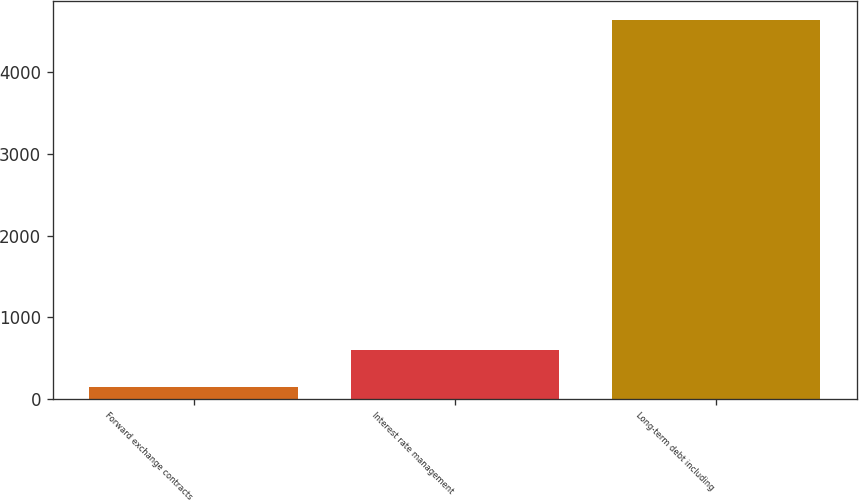<chart> <loc_0><loc_0><loc_500><loc_500><bar_chart><fcel>Forward exchange contracts<fcel>Interest rate management<fcel>Long-term debt including<nl><fcel>147.1<fcel>596.96<fcel>4645.7<nl></chart> 